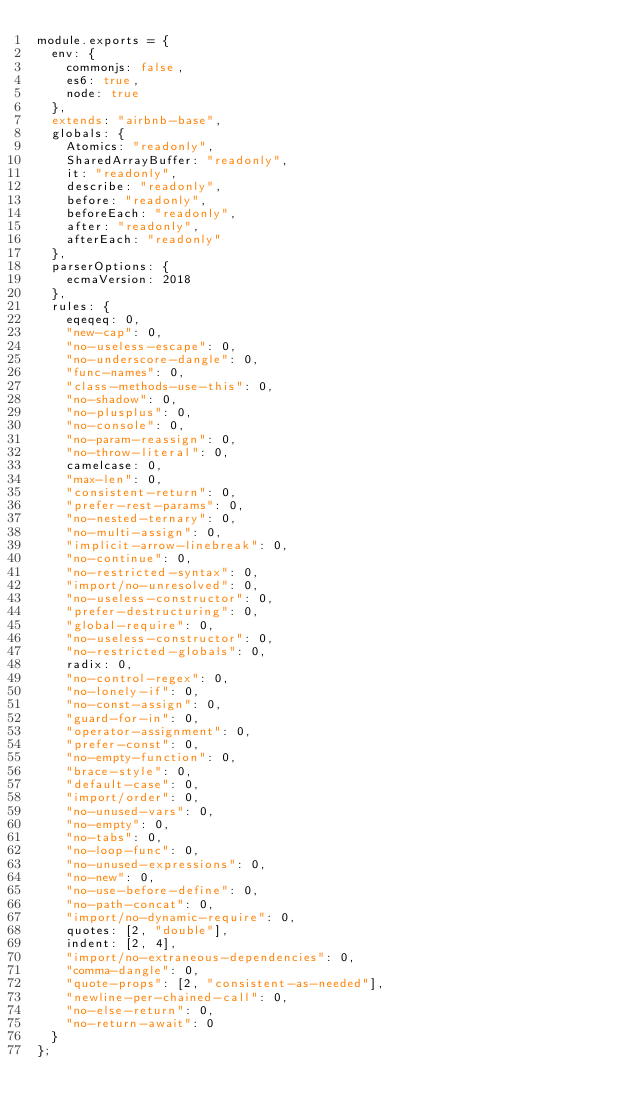<code> <loc_0><loc_0><loc_500><loc_500><_JavaScript_>module.exports = {
  env: {
    commonjs: false,
    es6: true,
    node: true
  },
  extends: "airbnb-base",
  globals: {
    Atomics: "readonly",
    SharedArrayBuffer: "readonly",
    it: "readonly",
    describe: "readonly",
    before: "readonly",
    beforeEach: "readonly",
    after: "readonly",
    afterEach: "readonly"
  },
  parserOptions: {
    ecmaVersion: 2018
  },
  rules: {
    eqeqeq: 0,
    "new-cap": 0,
    "no-useless-escape": 0,
    "no-underscore-dangle": 0,
    "func-names": 0,
    "class-methods-use-this": 0,
    "no-shadow": 0,
    "no-plusplus": 0,
    "no-console": 0,
    "no-param-reassign": 0,
    "no-throw-literal": 0,
    camelcase: 0,
    "max-len": 0,
    "consistent-return": 0,
    "prefer-rest-params": 0,
    "no-nested-ternary": 0,
    "no-multi-assign": 0,
    "implicit-arrow-linebreak": 0,
    "no-continue": 0,
    "no-restricted-syntax": 0,
    "import/no-unresolved": 0,
    "no-useless-constructor": 0,
    "prefer-destructuring": 0,
    "global-require": 0,
    "no-useless-constructor": 0,
    "no-restricted-globals": 0,
    radix: 0,
    "no-control-regex": 0,
    "no-lonely-if": 0,
    "no-const-assign": 0,
    "guard-for-in": 0,
    "operator-assignment": 0,
    "prefer-const": 0,
    "no-empty-function": 0,
    "brace-style": 0,
    "default-case": 0,
    "import/order": 0,
    "no-unused-vars": 0,
    "no-empty": 0,
    "no-tabs": 0,
    "no-loop-func": 0,
    "no-unused-expressions": 0,
    "no-new": 0,
    "no-use-before-define": 0,
    "no-path-concat": 0,
    "import/no-dynamic-require": 0,
    quotes: [2, "double"],
    indent: [2, 4],
    "import/no-extraneous-dependencies": 0,
    "comma-dangle": 0,
    "quote-props": [2, "consistent-as-needed"],
    "newline-per-chained-call": 0,
    "no-else-return": 0,
    "no-return-await": 0
  }
};
</code> 